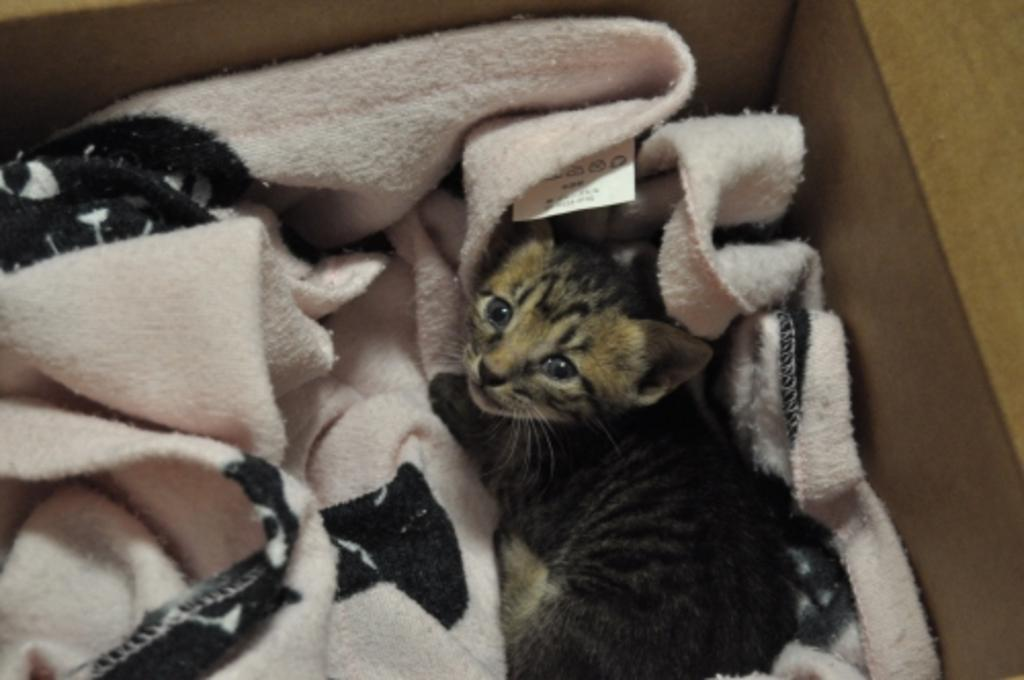What type of animal is present in the image? There is a cat in the image. What other object can be seen in the image? There is a cloth in the image. What type of island can be seen in the image? There is no island present in the image; it features a cat and a cloth. Are there any bats visible in the image? There are no bats present in the image. 